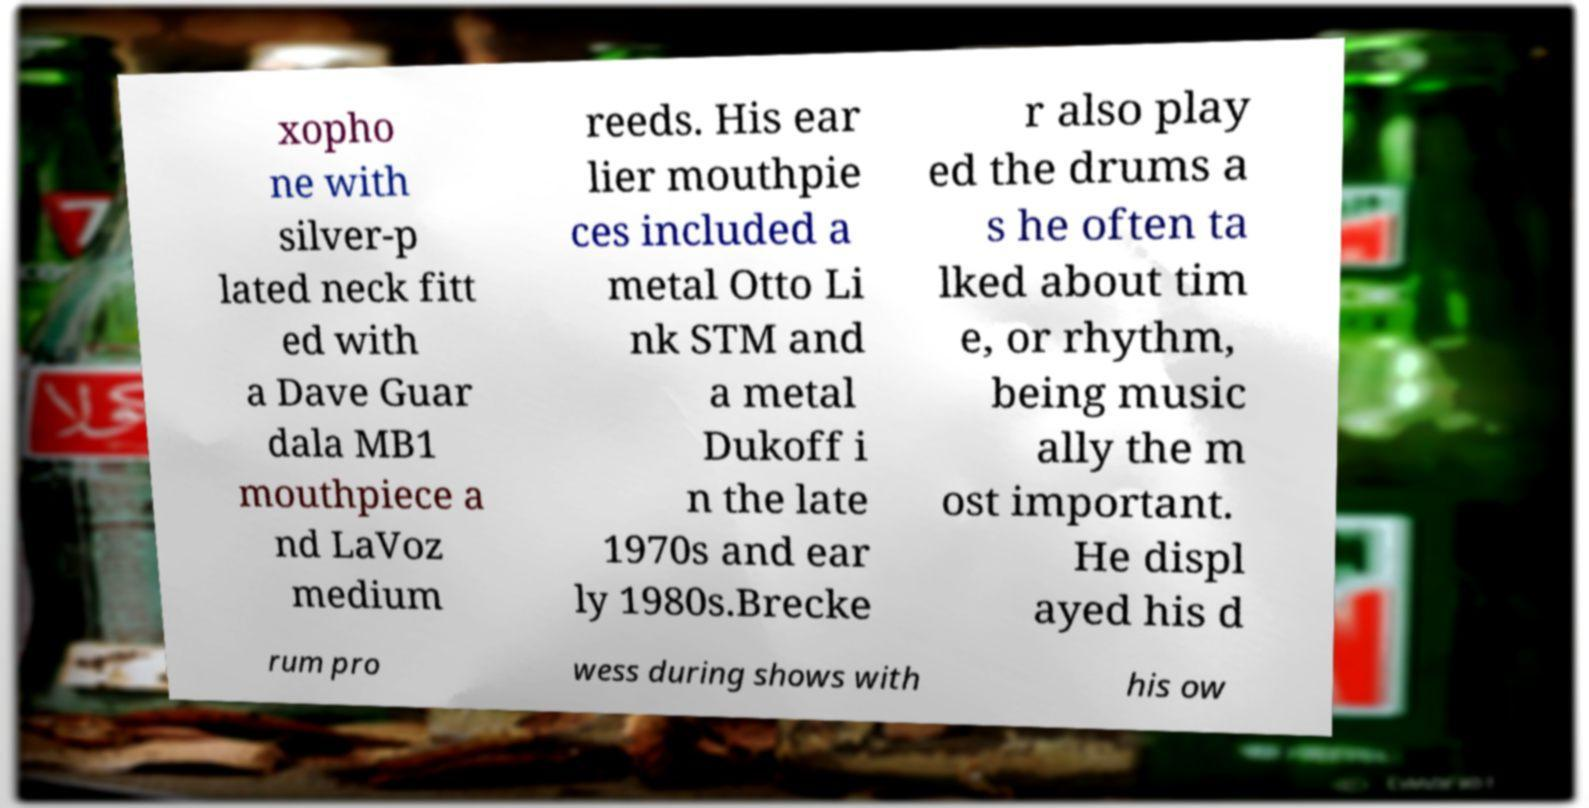Please read and relay the text visible in this image. What does it say? xopho ne with silver-p lated neck fitt ed with a Dave Guar dala MB1 mouthpiece a nd LaVoz medium reeds. His ear lier mouthpie ces included a metal Otto Li nk STM and a metal Dukoff i n the late 1970s and ear ly 1980s.Brecke r also play ed the drums a s he often ta lked about tim e, or rhythm, being music ally the m ost important. He displ ayed his d rum pro wess during shows with his ow 